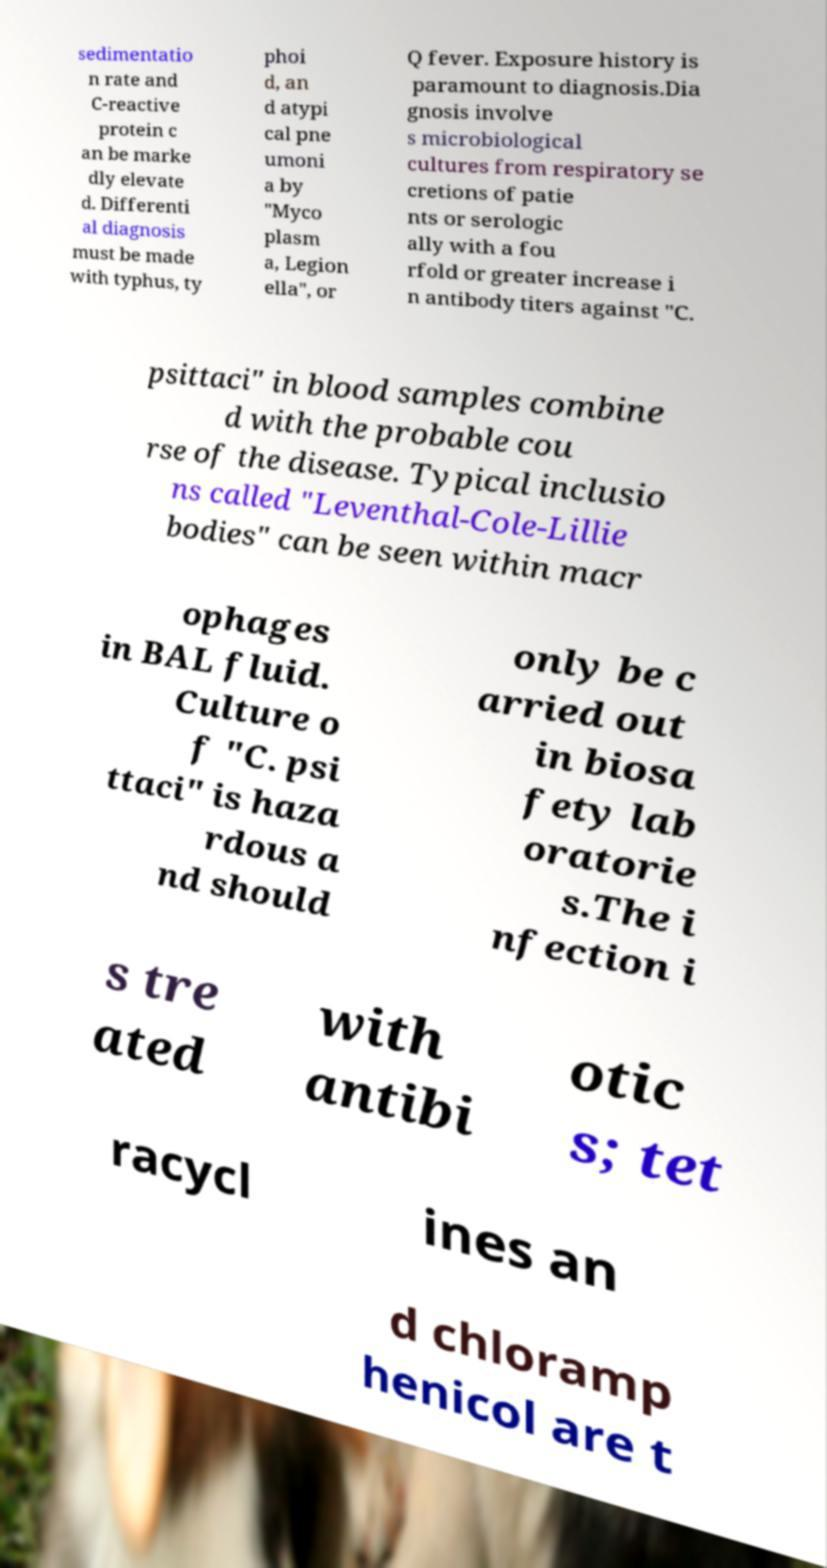Please read and relay the text visible in this image. What does it say? sedimentatio n rate and C-reactive protein c an be marke dly elevate d. Differenti al diagnosis must be made with typhus, ty phoi d, an d atypi cal pne umoni a by "Myco plasm a, Legion ella", or Q fever. Exposure history is paramount to diagnosis.Dia gnosis involve s microbiological cultures from respiratory se cretions of patie nts or serologic ally with a fou rfold or greater increase i n antibody titers against "C. psittaci" in blood samples combine d with the probable cou rse of the disease. Typical inclusio ns called "Leventhal-Cole-Lillie bodies" can be seen within macr ophages in BAL fluid. Culture o f "C. psi ttaci" is haza rdous a nd should only be c arried out in biosa fety lab oratorie s.The i nfection i s tre ated with antibi otic s; tet racycl ines an d chloramp henicol are t 